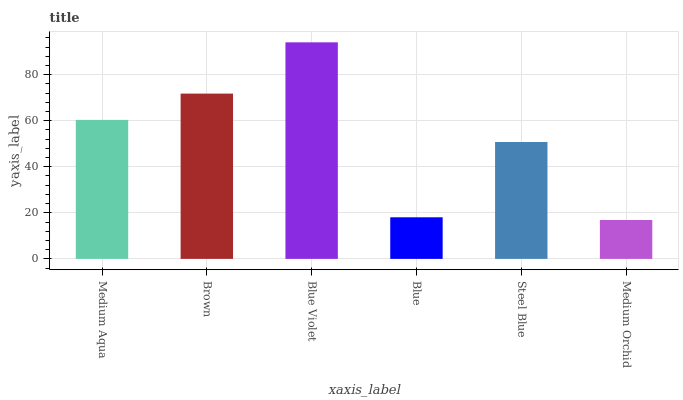Is Medium Orchid the minimum?
Answer yes or no. Yes. Is Blue Violet the maximum?
Answer yes or no. Yes. Is Brown the minimum?
Answer yes or no. No. Is Brown the maximum?
Answer yes or no. No. Is Brown greater than Medium Aqua?
Answer yes or no. Yes. Is Medium Aqua less than Brown?
Answer yes or no. Yes. Is Medium Aqua greater than Brown?
Answer yes or no. No. Is Brown less than Medium Aqua?
Answer yes or no. No. Is Medium Aqua the high median?
Answer yes or no. Yes. Is Steel Blue the low median?
Answer yes or no. Yes. Is Blue Violet the high median?
Answer yes or no. No. Is Blue Violet the low median?
Answer yes or no. No. 